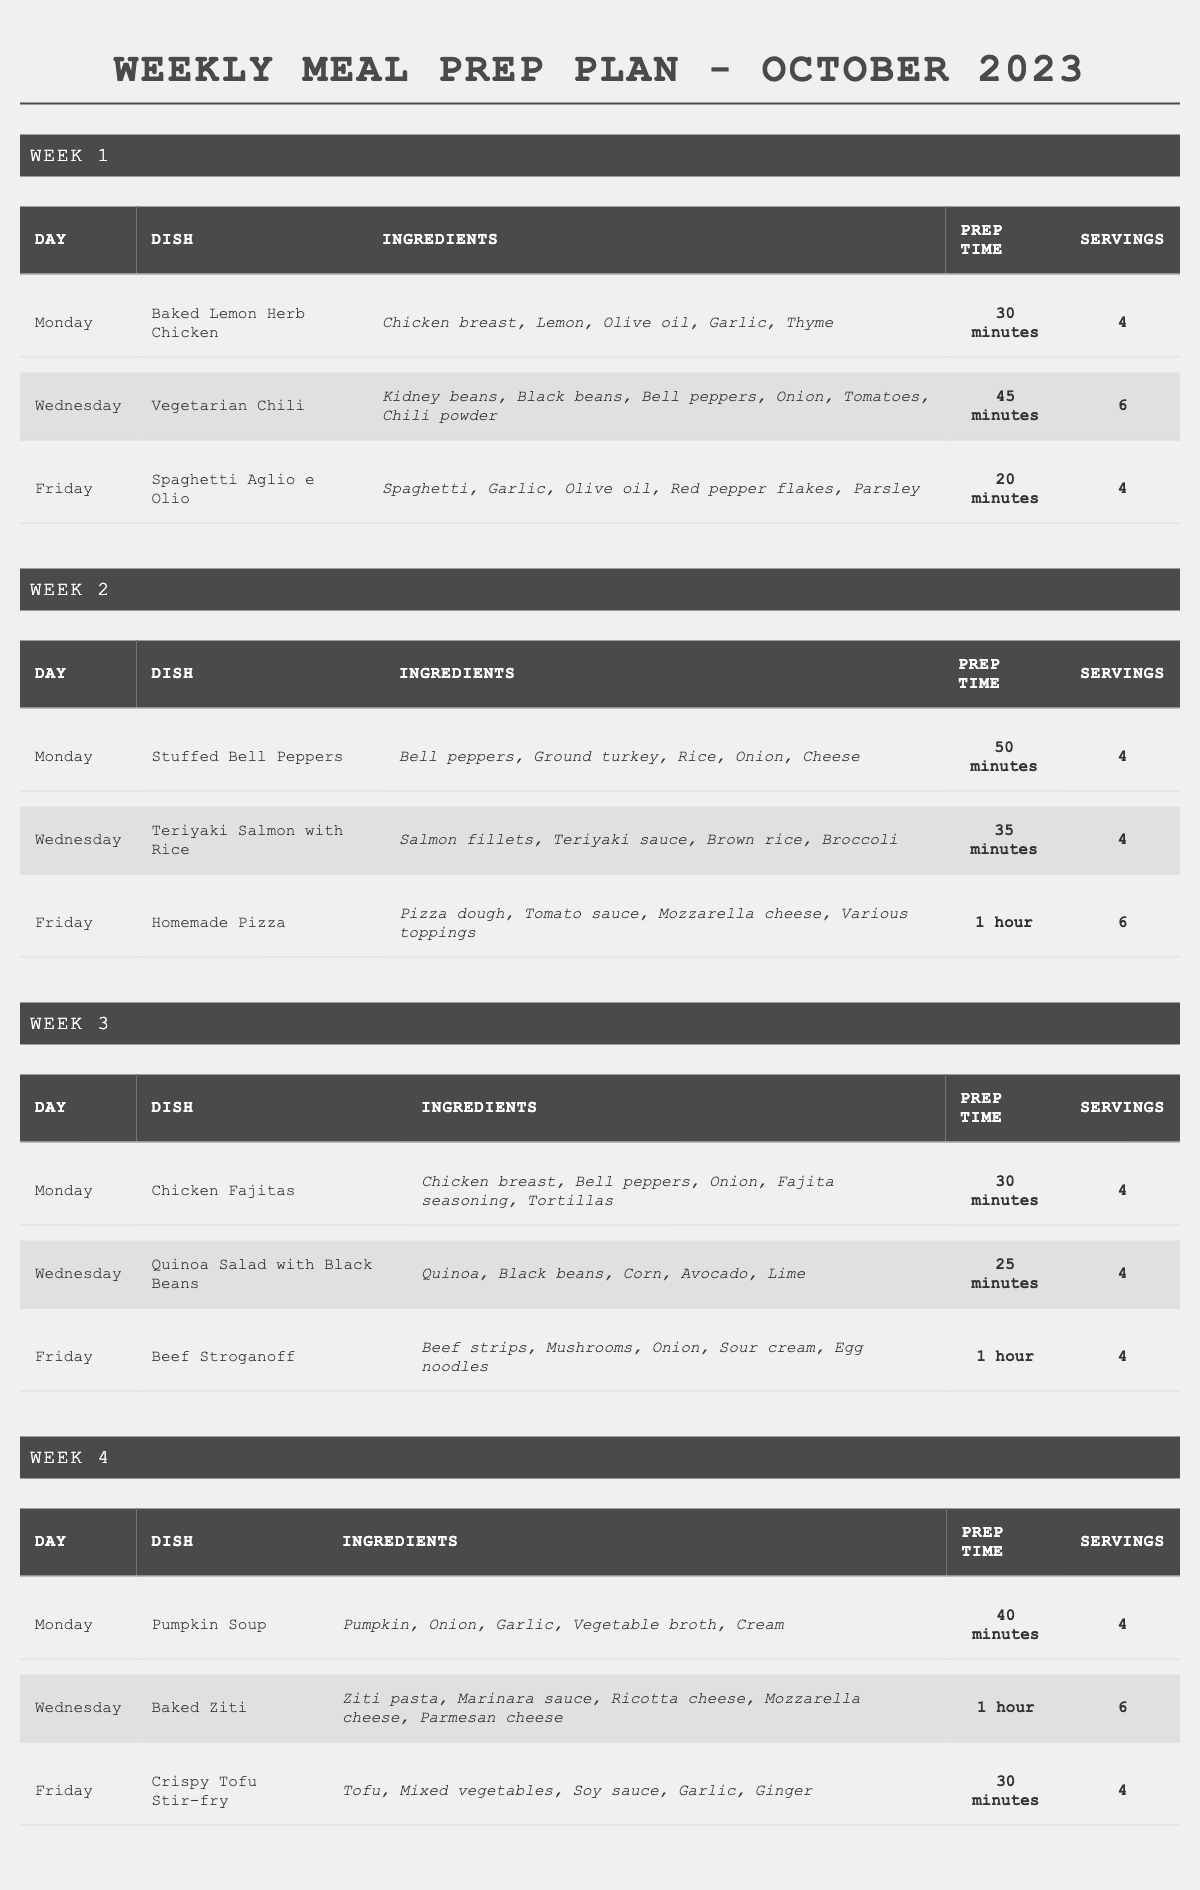What dish is served on Friday of week 2? The table indicates the dish for Friday of week 2 is "Homemade Pizza."
Answer: Homemade Pizza How many servings are there for the Baked Ziti dish? In the table, the servings listed for Baked Ziti are 6.
Answer: 6 What is the total prep time for the dishes on Monday of week 1 and Wednesday of week 1? The prep time for Monday (Baked Lemon Herb Chicken) is 30 minutes and for Wednesday (Vegetarian Chili) is 45 minutes. Adding these two gives a total prep time of 30 + 45 = 75 minutes.
Answer: 75 minutes Is there a dish featuring pumpkin in the meal prep plan? Yes, the dish "Pumpkin Soup" is included in the plan.
Answer: Yes What is the average prep time for the dishes in week 3? The dishes in week 3 are Chicken Fajitas (30 min), Quinoa Salad with Black Beans (25 min), and Beef Stroganoff (60 min). The total prep time is 30 + 25 + 60 = 115 minutes. There are 3 dishes, so the average prep time is 115/3, which is approximately 38.33 minutes.
Answer: 38.33 minutes Which dish takes the longest to prepare, and how long is the prep time? The table shows that "Homemade Pizza" takes 1 hour (60 minutes) to prepare, which is the longest time listed.
Answer: Homemade Pizza, 60 minutes On which days are vegetarian dishes served? The vegetarian dishes are "Vegetarian Chili" on Wednesday of week 1 and "Quinoa Salad with Black Beans" on Wednesday of week 3. Hence, vegetarian dishes are served on Wednesdays of week 1 and week 3.
Answer: Wednesdays of week 1 and week 3 How many total servings are planned for the dishes on Fridays throughout October? The dishes on Fridays are Spaghetti Aglio e Olio (4 servings), Homemade Pizza (6 servings), and Beef Stroganoff (4 servings) from weeks 1, 2, and 3 respectively. Adding these gives 4 + 6 + 4 = 14 servings planned for Fridays.
Answer: 14 servings What is the dish served on the Monday of week 4? According to the table, the dish served on Monday of week 4 is "Pumpkin Soup."
Answer: Pumpkin Soup How many different ingredients are used in the Friday menu items? The dishes on Fridays are Spaghetti Aglio e Olio, Homemade Pizza, and Beef Stroganoff. The unique ingredients are Spaghetti, Garlic, Olive oil, Red pepper flakes, Parsley, Pizza dough, Tomato sauce, Mozzarella cheese, Beef strips, Mushrooms, Onion, Sour cream, and Egg noodles. Counting these gives a total of 12 unique ingredients.
Answer: 12 unique ingredients 